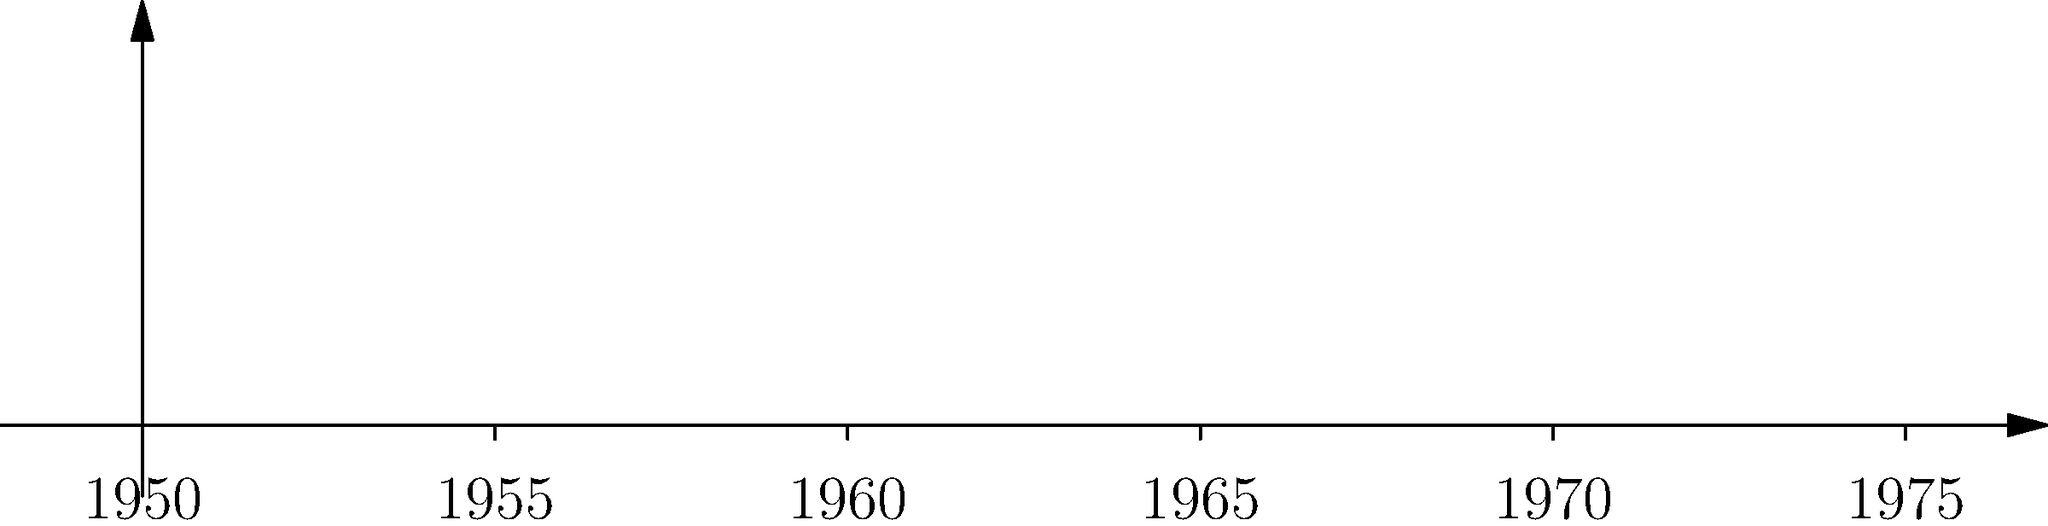Based on the timeline visualization of iconic advertising slogans, which slogan was introduced closest to the midpoint of the time period shown? To determine which slogan was introduced closest to the midpoint of the time period shown, we need to follow these steps:

1. Identify the time period shown:
   The timeline runs from 1950 to 1975, covering a span of 25 years.

2. Calculate the midpoint of the time period:
   Midpoint = 1950 + (1975 - 1950) / 2 = 1950 + 12.5 = 1962.5

3. List the slogans and their introduction years:
   - "A DIAMOND IS FOREVER" (1948)
   - "THE PAUSE THAT REFRESHES" (1929)
   - "FINGER-LICKIN' GOOD" (1956)
   - "PLOP, PLOP, FIZZ, FIZZ" (1975)
   - "I'D LIKE TO BUY THE WORLD A COKE" (1971)

4. Calculate the difference between each slogan's introduction year and the midpoint (1962.5):
   - "A DIAMOND IS FOREVER": |1948 - 1962.5| = 14.5 years
   - "THE PAUSE THAT REFRESHES": |1929 - 1962.5| = 33.5 years
   - "FINGER-LICKIN' GOOD": |1956 - 1962.5| = 6.5 years
   - "PLOP, PLOP, FIZZ, FIZZ": |1975 - 1962.5| = 12.5 years
   - "I'D LIKE TO BUY THE WORLD A COKE": |1971 - 1962.5| = 8.5 years

5. Identify the slogan with the smallest difference:
   The smallest difference is 6.5 years, corresponding to "FINGER-LICKIN' GOOD".

Therefore, "FINGER-LICKIN' GOOD" was introduced closest to the midpoint of the time period shown.
Answer: FINGER-LICKIN' GOOD 